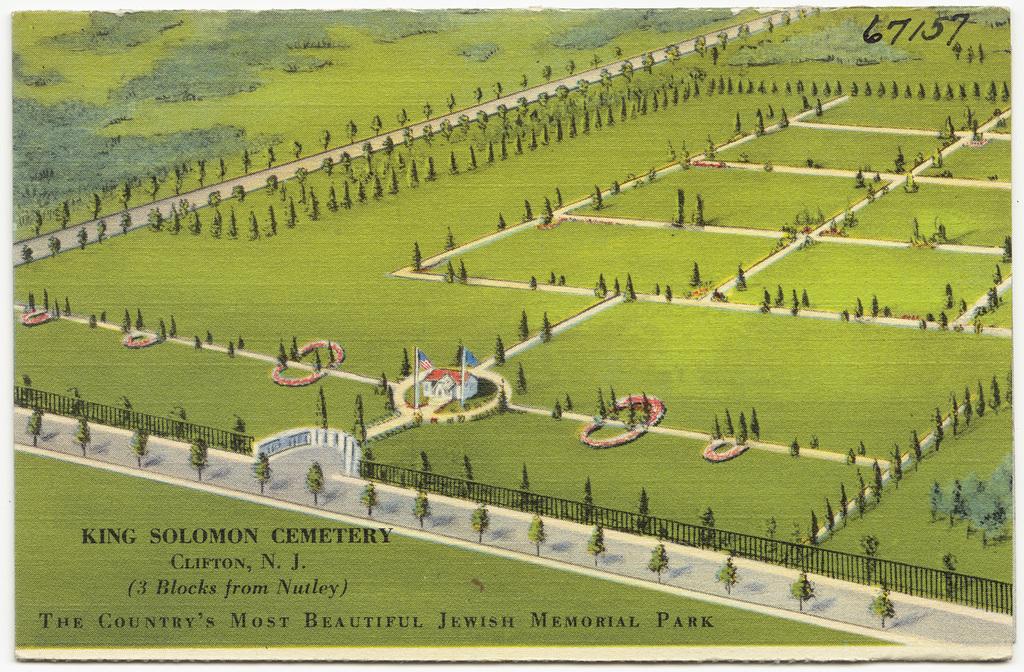What is 3 blocks from nutley?
Give a very brief answer. King solomon cemetery. Who is the cemetery named after?
Provide a succinct answer. King solomon. 